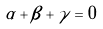<formula> <loc_0><loc_0><loc_500><loc_500>\alpha + \beta + \gamma = 0</formula> 